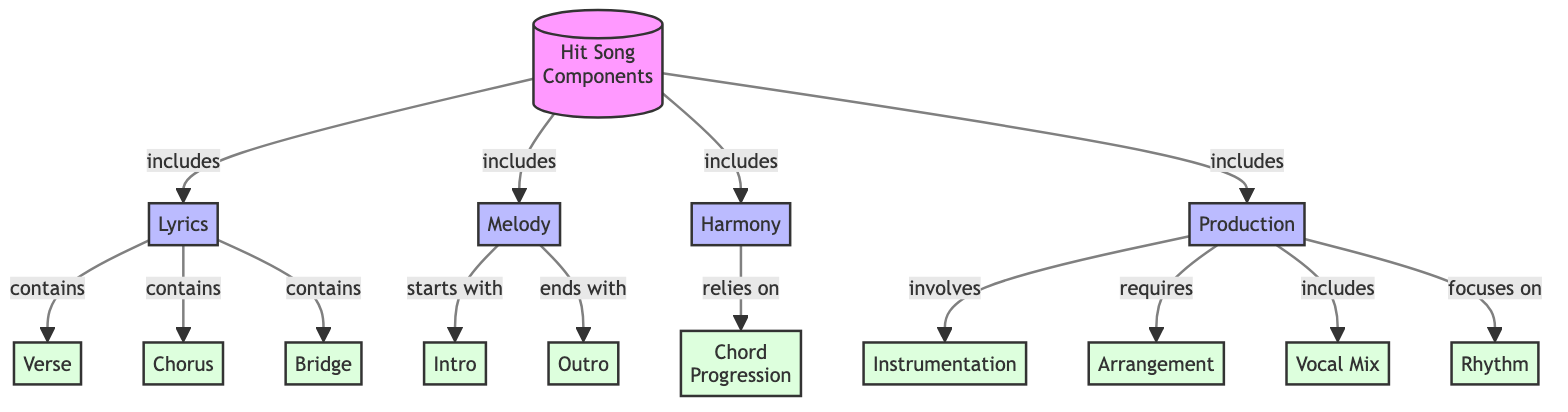What are the main components of a hit song? The diagram represents four main components, which are Lyrics, Melody, Harmony, and Production, each depicted as a separate node directly stemming from the central node "Hit Song Components."
Answer: Lyrics, Melody, Harmony, Production How many subcomponents are included under Lyrics? Under the Lyrics node, there are three subcomponents: Verse, Chorus, and Bridge. This is obtained by counting the nodes that are connected to the Lyrics node.
Answer: 3 Which component includes Instrumentation as a subcomponent? The Production node includes Instrumentation as one of its subcomponents. This is determined by tracing the connections from the Production node to its subcomponents.
Answer: Production What relationship does Harmony have with Chord Progression? Harmony relies on Chord Progression, which is indicated in the diagram through a directed edge from Harmony to Chord Progression, emphasizing their interdependency.
Answer: relies on Which part of the Melody does the diagram indicate comes first? The diagram indicates that the Intro comes first in the structure of the Melody, as the connection from the Melody node points to the Intro subcomponent.
Answer: Intro How many total components are there in this diagram, including both main and subcomponents? There are a total of 14 components, consisting of 4 main components (Lyrics, Melody, Harmony, Production) and 10 subcomponents (Verse, Chorus, Bridge, Intro, Outro, Chord Progression, Instrumentation, Arrangement, Vocal Mix, Rhythm). To arrive at this count, simply sum the main and subcomponents.
Answer: 14 Which component has the highest number of subcomponents in this diagram? The Production component has the highest number of subcomponents, comprising 5 distinct elements: Instrumentation, Arrangement, Vocal Mix, Rhythm, and requires the most connections. This is observed by counting the subcomponents connected to each main component.
Answer: Production What does the arrow from Hit Song Components to Harmony signify? The arrow signifies that Harmony is a main component of a hit song, indicating its importance in the overall structure. This relationship is evident from the directed connection in the diagram.
Answer: includes Which two components directly influence the structure of a hit song by including subcomponents? Both Lyrics and Production directly influence the structure by including subcomponents, as shown by their connections to multiple subcomponents. This is determined by reviewing the diagram for nodes that have further subdivisions.
Answer: Lyrics, Production 